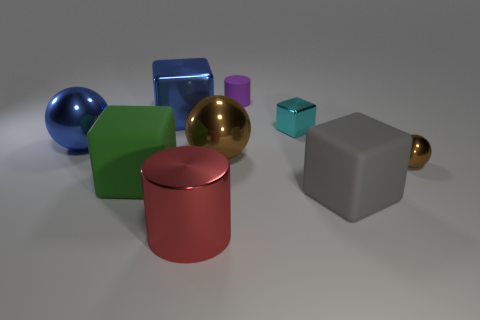Subtract all small metallic cubes. How many cubes are left? 3 Add 1 tiny purple objects. How many objects exist? 10 Subtract all green blocks. How many blocks are left? 3 Subtract 1 cubes. How many cubes are left? 3 Add 3 big red metal cylinders. How many big red metal cylinders exist? 4 Subtract 0 red spheres. How many objects are left? 9 Subtract all spheres. How many objects are left? 6 Subtract all brown cubes. Subtract all purple cylinders. How many cubes are left? 4 Subtract all blue spheres. How many cyan cubes are left? 1 Subtract all large gray cubes. Subtract all gray things. How many objects are left? 7 